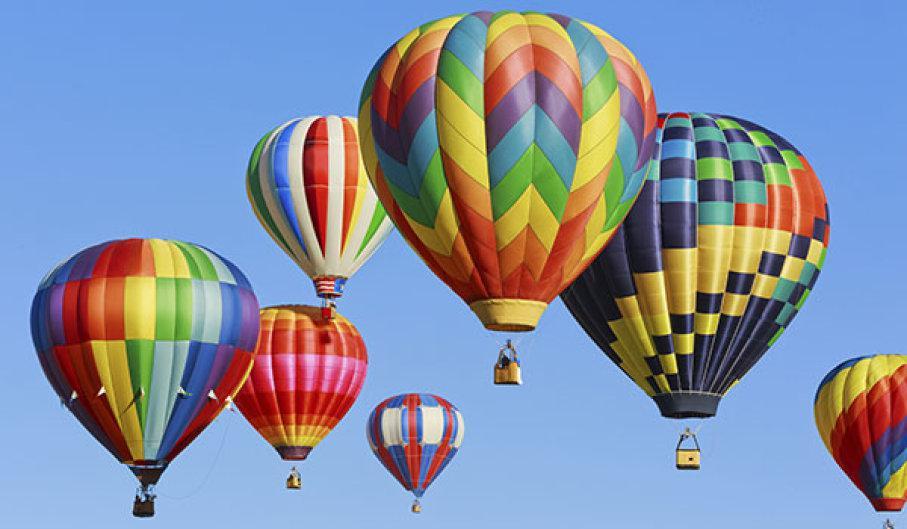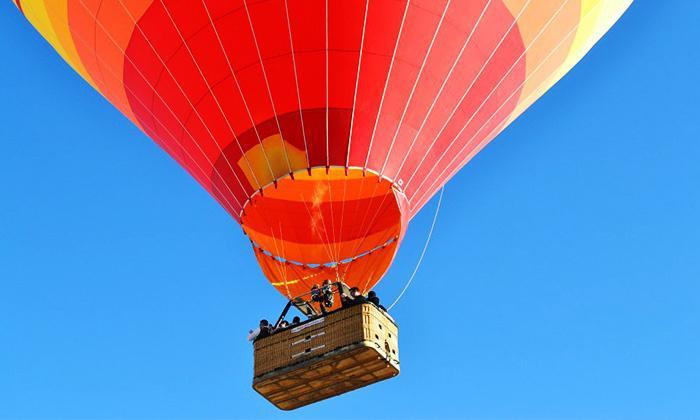The first image is the image on the left, the second image is the image on the right. Considering the images on both sides, is "There are more than 5 balloons in one of the images." valid? Answer yes or no. Yes. 